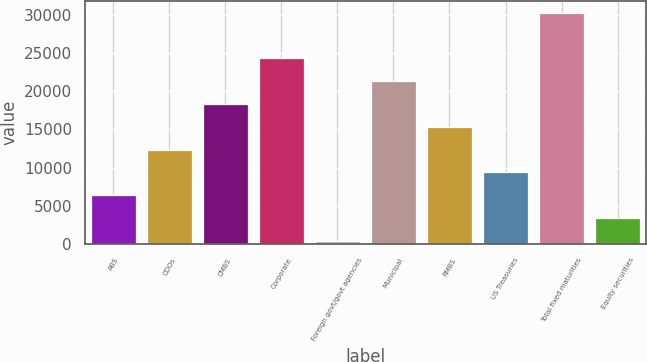<chart> <loc_0><loc_0><loc_500><loc_500><bar_chart><fcel>ABS<fcel>CDOs<fcel>CMBS<fcel>Corporate<fcel>Foreign govt/govt agencies<fcel>Municipal<fcel>RMBS<fcel>US Treasuries<fcel>Total fixed maturities<fcel>Equity securities<nl><fcel>6392<fcel>12367<fcel>18342<fcel>24317<fcel>417<fcel>21329.5<fcel>15354.5<fcel>9379.5<fcel>30292<fcel>3404.5<nl></chart> 